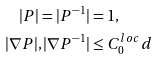<formula> <loc_0><loc_0><loc_500><loc_500>| P | = | P ^ { - 1 } | & = 1 , \\ | \nabla P | , | \nabla P ^ { - 1 } | & \leq C ^ { l o c } _ { 0 } d</formula> 